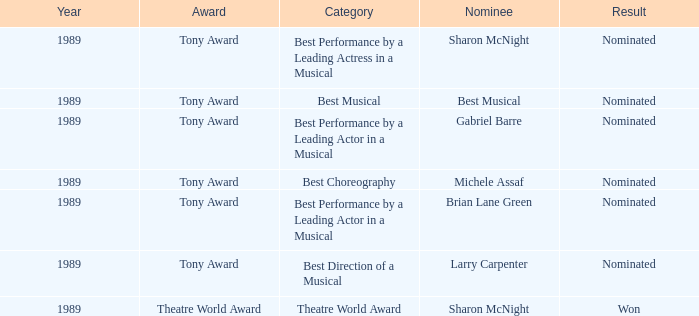What year was michele assaf nominated 1989.0. 